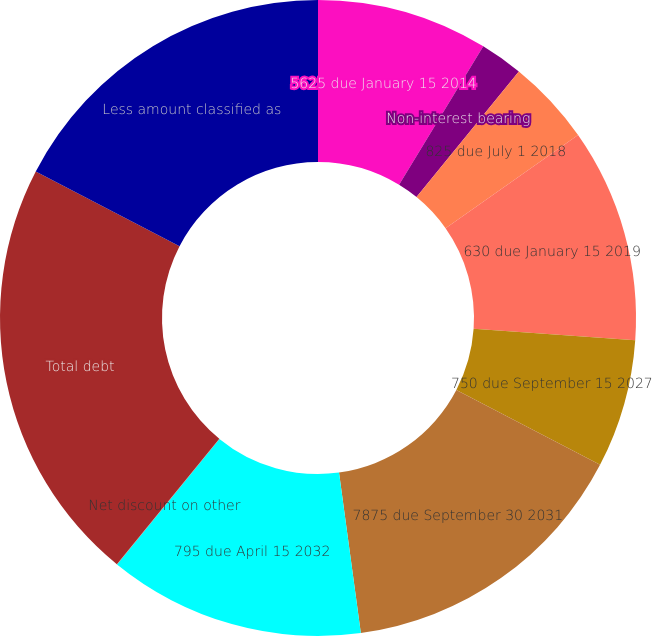<chart> <loc_0><loc_0><loc_500><loc_500><pie_chart><fcel>5625 due January 15 2014<fcel>Non-interest bearing<fcel>825 due July 1 2018<fcel>630 due January 15 2019<fcel>750 due September 15 2027<fcel>7875 due September 30 2031<fcel>795 due April 15 2032<fcel>Net discount on other<fcel>Total debt<fcel>Less amount classified as<nl><fcel>8.7%<fcel>2.18%<fcel>4.36%<fcel>10.87%<fcel>6.53%<fcel>15.21%<fcel>13.04%<fcel>0.01%<fcel>21.72%<fcel>17.38%<nl></chart> 